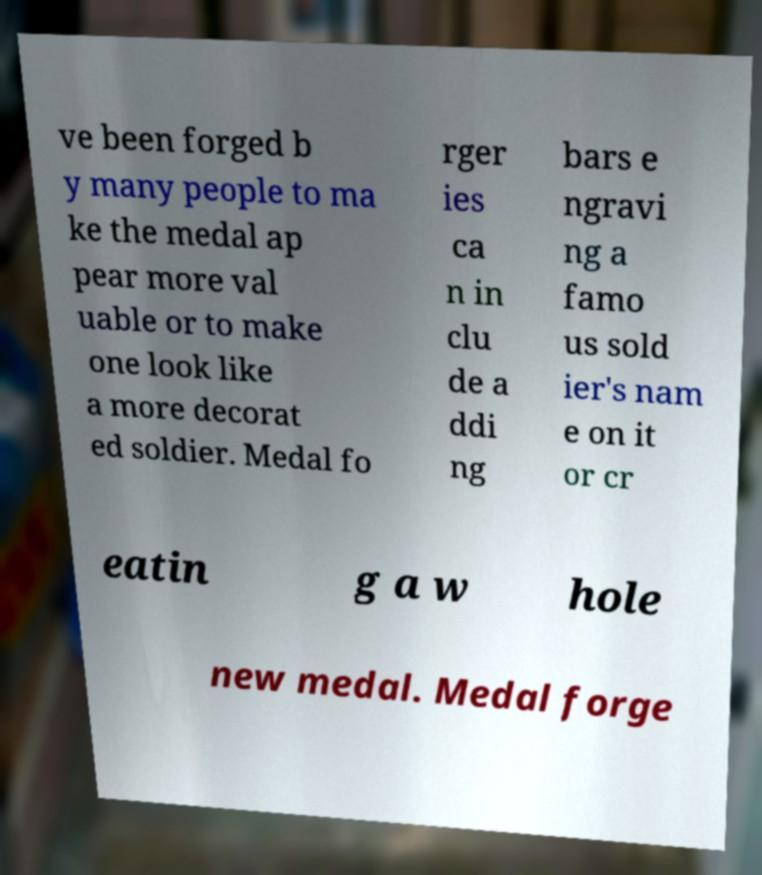There's text embedded in this image that I need extracted. Can you transcribe it verbatim? ve been forged b y many people to ma ke the medal ap pear more val uable or to make one look like a more decorat ed soldier. Medal fo rger ies ca n in clu de a ddi ng bars e ngravi ng a famo us sold ier's nam e on it or cr eatin g a w hole new medal. Medal forge 